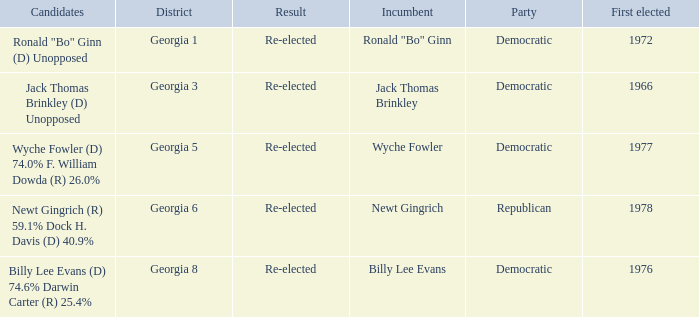What is the party with the candidates newt gingrich (r) 59.1% dock h. davis (d) 40.9%? Republican. 